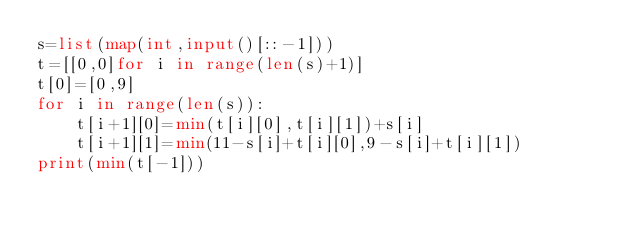<code> <loc_0><loc_0><loc_500><loc_500><_Python_>s=list(map(int,input()[::-1]))
t=[[0,0]for i in range(len(s)+1)]
t[0]=[0,9]
for i in range(len(s)):
    t[i+1][0]=min(t[i][0],t[i][1])+s[i]
    t[i+1][1]=min(11-s[i]+t[i][0],9-s[i]+t[i][1])
print(min(t[-1]))</code> 